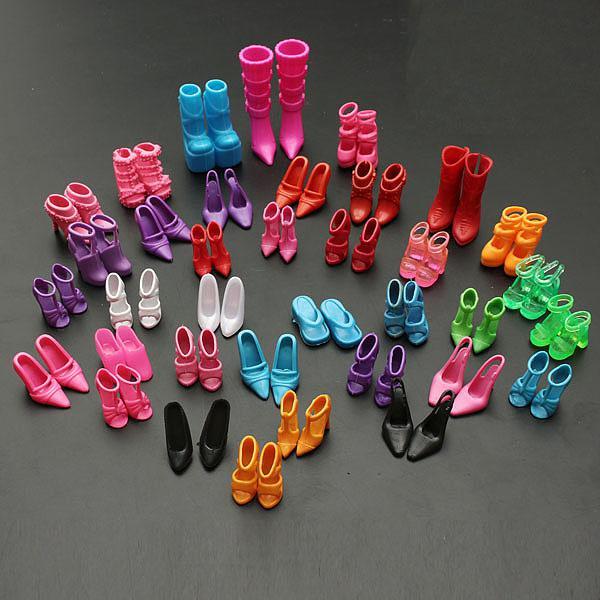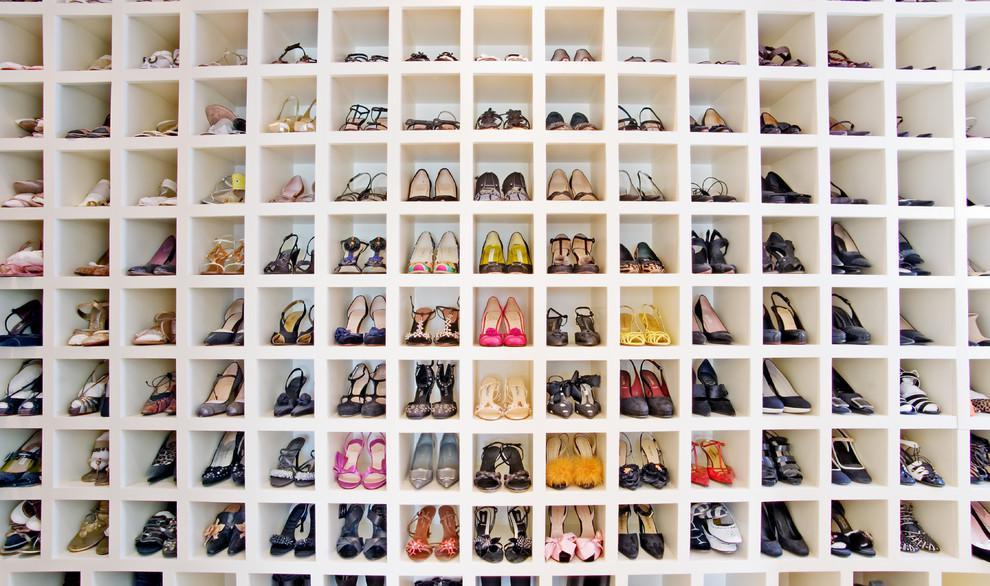The first image is the image on the left, the second image is the image on the right. Analyze the images presented: Is the assertion "The left image shows at least a dozen shoe pairs arranged on a wood floor, and the right image shows a messy pile of sneakers." valid? Answer yes or no. No. The first image is the image on the left, the second image is the image on the right. For the images displayed, is the sentence "There are fifteen pairs of shoes in the left image." factually correct? Answer yes or no. No. 